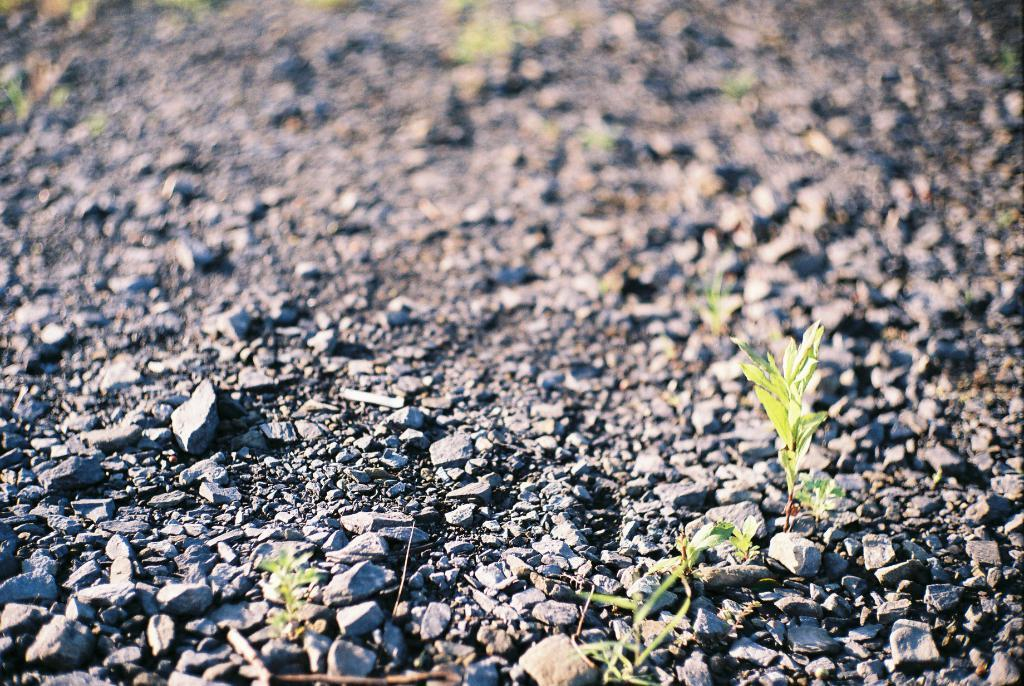What can be seen underfoot in the image? The ground is visible in the image. Are there any specific features on the ground? Yes, there are stones on the ground. What else is present in the image besides the ground? Plants are present in the image. Can you describe the background of the image? The background of the image is blurred. Where is the key hidden in the image? There is no key present in the image. 